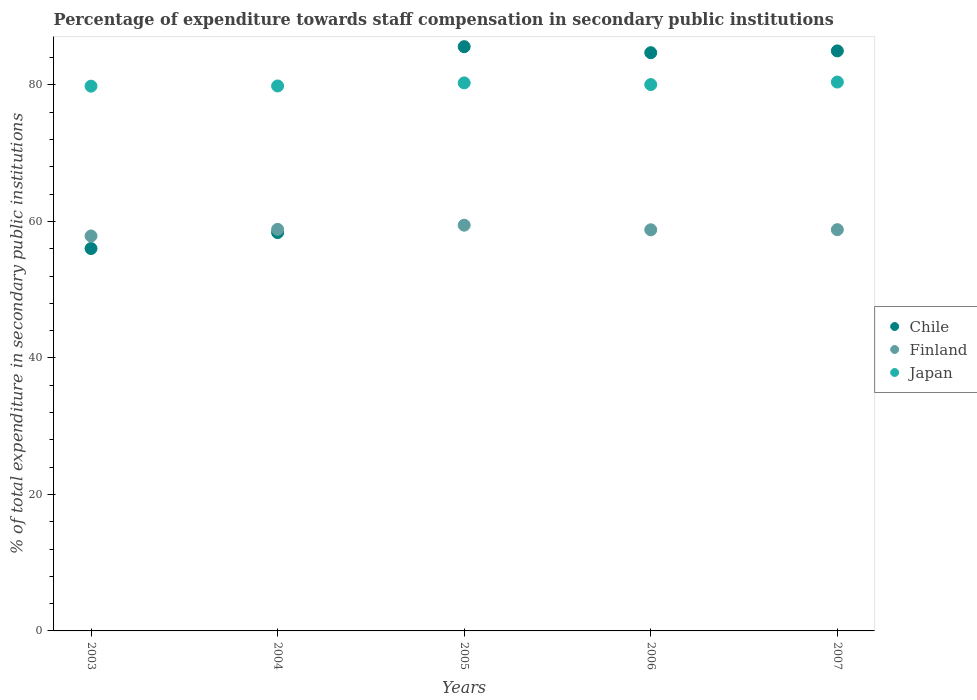How many different coloured dotlines are there?
Offer a terse response. 3. Is the number of dotlines equal to the number of legend labels?
Offer a very short reply. Yes. What is the percentage of expenditure towards staff compensation in Chile in 2005?
Your answer should be very brief. 85.61. Across all years, what is the maximum percentage of expenditure towards staff compensation in Finland?
Offer a terse response. 59.45. Across all years, what is the minimum percentage of expenditure towards staff compensation in Finland?
Make the answer very short. 57.87. In which year was the percentage of expenditure towards staff compensation in Chile maximum?
Your response must be concise. 2005. In which year was the percentage of expenditure towards staff compensation in Chile minimum?
Offer a terse response. 2003. What is the total percentage of expenditure towards staff compensation in Chile in the graph?
Provide a short and direct response. 369.73. What is the difference between the percentage of expenditure towards staff compensation in Japan in 2003 and that in 2005?
Offer a terse response. -0.48. What is the difference between the percentage of expenditure towards staff compensation in Japan in 2006 and the percentage of expenditure towards staff compensation in Finland in 2007?
Keep it short and to the point. 21.26. What is the average percentage of expenditure towards staff compensation in Finland per year?
Provide a short and direct response. 58.75. In the year 2007, what is the difference between the percentage of expenditure towards staff compensation in Chile and percentage of expenditure towards staff compensation in Finland?
Ensure brevity in your answer.  26.2. What is the ratio of the percentage of expenditure towards staff compensation in Chile in 2005 to that in 2006?
Offer a very short reply. 1.01. What is the difference between the highest and the second highest percentage of expenditure towards staff compensation in Japan?
Your response must be concise. 0.12. What is the difference between the highest and the lowest percentage of expenditure towards staff compensation in Chile?
Provide a succinct answer. 29.58. In how many years, is the percentage of expenditure towards staff compensation in Finland greater than the average percentage of expenditure towards staff compensation in Finland taken over all years?
Give a very brief answer. 4. Is the sum of the percentage of expenditure towards staff compensation in Japan in 2003 and 2006 greater than the maximum percentage of expenditure towards staff compensation in Chile across all years?
Offer a terse response. Yes. Does the percentage of expenditure towards staff compensation in Chile monotonically increase over the years?
Ensure brevity in your answer.  No. Is the percentage of expenditure towards staff compensation in Chile strictly greater than the percentage of expenditure towards staff compensation in Japan over the years?
Your answer should be very brief. No. Is the percentage of expenditure towards staff compensation in Japan strictly less than the percentage of expenditure towards staff compensation in Chile over the years?
Your answer should be very brief. No. How many dotlines are there?
Ensure brevity in your answer.  3. Where does the legend appear in the graph?
Your answer should be compact. Center right. What is the title of the graph?
Your answer should be compact. Percentage of expenditure towards staff compensation in secondary public institutions. What is the label or title of the X-axis?
Keep it short and to the point. Years. What is the label or title of the Y-axis?
Provide a short and direct response. % of total expenditure in secondary public institutions. What is the % of total expenditure in secondary public institutions in Chile in 2003?
Make the answer very short. 56.03. What is the % of total expenditure in secondary public institutions in Finland in 2003?
Give a very brief answer. 57.87. What is the % of total expenditure in secondary public institutions of Japan in 2003?
Keep it short and to the point. 79.82. What is the % of total expenditure in secondary public institutions in Chile in 2004?
Offer a very short reply. 58.37. What is the % of total expenditure in secondary public institutions of Finland in 2004?
Provide a succinct answer. 58.84. What is the % of total expenditure in secondary public institutions in Japan in 2004?
Your answer should be very brief. 79.85. What is the % of total expenditure in secondary public institutions in Chile in 2005?
Make the answer very short. 85.61. What is the % of total expenditure in secondary public institutions of Finland in 2005?
Provide a succinct answer. 59.45. What is the % of total expenditure in secondary public institutions of Japan in 2005?
Give a very brief answer. 80.3. What is the % of total expenditure in secondary public institutions of Chile in 2006?
Your answer should be very brief. 84.73. What is the % of total expenditure in secondary public institutions of Finland in 2006?
Your answer should be very brief. 58.78. What is the % of total expenditure in secondary public institutions in Japan in 2006?
Offer a terse response. 80.06. What is the % of total expenditure in secondary public institutions in Chile in 2007?
Offer a terse response. 84.99. What is the % of total expenditure in secondary public institutions of Finland in 2007?
Keep it short and to the point. 58.8. What is the % of total expenditure in secondary public institutions in Japan in 2007?
Your answer should be compact. 80.43. Across all years, what is the maximum % of total expenditure in secondary public institutions of Chile?
Your response must be concise. 85.61. Across all years, what is the maximum % of total expenditure in secondary public institutions in Finland?
Your answer should be very brief. 59.45. Across all years, what is the maximum % of total expenditure in secondary public institutions in Japan?
Your answer should be compact. 80.43. Across all years, what is the minimum % of total expenditure in secondary public institutions of Chile?
Offer a terse response. 56.03. Across all years, what is the minimum % of total expenditure in secondary public institutions in Finland?
Offer a very short reply. 57.87. Across all years, what is the minimum % of total expenditure in secondary public institutions of Japan?
Ensure brevity in your answer.  79.82. What is the total % of total expenditure in secondary public institutions in Chile in the graph?
Give a very brief answer. 369.73. What is the total % of total expenditure in secondary public institutions of Finland in the graph?
Your answer should be compact. 293.74. What is the total % of total expenditure in secondary public institutions of Japan in the graph?
Provide a short and direct response. 400.47. What is the difference between the % of total expenditure in secondary public institutions in Chile in 2003 and that in 2004?
Your response must be concise. -2.33. What is the difference between the % of total expenditure in secondary public institutions in Finland in 2003 and that in 2004?
Make the answer very short. -0.97. What is the difference between the % of total expenditure in secondary public institutions of Japan in 2003 and that in 2004?
Provide a short and direct response. -0.03. What is the difference between the % of total expenditure in secondary public institutions in Chile in 2003 and that in 2005?
Offer a terse response. -29.58. What is the difference between the % of total expenditure in secondary public institutions of Finland in 2003 and that in 2005?
Make the answer very short. -1.58. What is the difference between the % of total expenditure in secondary public institutions in Japan in 2003 and that in 2005?
Keep it short and to the point. -0.48. What is the difference between the % of total expenditure in secondary public institutions in Chile in 2003 and that in 2006?
Keep it short and to the point. -28.7. What is the difference between the % of total expenditure in secondary public institutions of Finland in 2003 and that in 2006?
Provide a succinct answer. -0.9. What is the difference between the % of total expenditure in secondary public institutions of Japan in 2003 and that in 2006?
Your answer should be very brief. -0.24. What is the difference between the % of total expenditure in secondary public institutions in Chile in 2003 and that in 2007?
Offer a very short reply. -28.96. What is the difference between the % of total expenditure in secondary public institutions in Finland in 2003 and that in 2007?
Make the answer very short. -0.92. What is the difference between the % of total expenditure in secondary public institutions of Japan in 2003 and that in 2007?
Keep it short and to the point. -0.6. What is the difference between the % of total expenditure in secondary public institutions in Chile in 2004 and that in 2005?
Ensure brevity in your answer.  -27.24. What is the difference between the % of total expenditure in secondary public institutions in Finland in 2004 and that in 2005?
Offer a very short reply. -0.61. What is the difference between the % of total expenditure in secondary public institutions of Japan in 2004 and that in 2005?
Your answer should be very brief. -0.45. What is the difference between the % of total expenditure in secondary public institutions in Chile in 2004 and that in 2006?
Provide a short and direct response. -26.36. What is the difference between the % of total expenditure in secondary public institutions of Finland in 2004 and that in 2006?
Provide a short and direct response. 0.07. What is the difference between the % of total expenditure in secondary public institutions in Japan in 2004 and that in 2006?
Offer a very short reply. -0.2. What is the difference between the % of total expenditure in secondary public institutions of Chile in 2004 and that in 2007?
Your response must be concise. -26.63. What is the difference between the % of total expenditure in secondary public institutions in Finland in 2004 and that in 2007?
Ensure brevity in your answer.  0.05. What is the difference between the % of total expenditure in secondary public institutions in Japan in 2004 and that in 2007?
Offer a very short reply. -0.57. What is the difference between the % of total expenditure in secondary public institutions in Chile in 2005 and that in 2006?
Your answer should be compact. 0.88. What is the difference between the % of total expenditure in secondary public institutions in Finland in 2005 and that in 2006?
Your answer should be compact. 0.68. What is the difference between the % of total expenditure in secondary public institutions of Japan in 2005 and that in 2006?
Give a very brief answer. 0.24. What is the difference between the % of total expenditure in secondary public institutions in Chile in 2005 and that in 2007?
Your answer should be very brief. 0.62. What is the difference between the % of total expenditure in secondary public institutions in Finland in 2005 and that in 2007?
Make the answer very short. 0.66. What is the difference between the % of total expenditure in secondary public institutions of Japan in 2005 and that in 2007?
Offer a terse response. -0.12. What is the difference between the % of total expenditure in secondary public institutions of Chile in 2006 and that in 2007?
Give a very brief answer. -0.26. What is the difference between the % of total expenditure in secondary public institutions in Finland in 2006 and that in 2007?
Provide a succinct answer. -0.02. What is the difference between the % of total expenditure in secondary public institutions in Japan in 2006 and that in 2007?
Ensure brevity in your answer.  -0.37. What is the difference between the % of total expenditure in secondary public institutions in Chile in 2003 and the % of total expenditure in secondary public institutions in Finland in 2004?
Provide a succinct answer. -2.81. What is the difference between the % of total expenditure in secondary public institutions in Chile in 2003 and the % of total expenditure in secondary public institutions in Japan in 2004?
Your response must be concise. -23.82. What is the difference between the % of total expenditure in secondary public institutions of Finland in 2003 and the % of total expenditure in secondary public institutions of Japan in 2004?
Provide a short and direct response. -21.98. What is the difference between the % of total expenditure in secondary public institutions of Chile in 2003 and the % of total expenditure in secondary public institutions of Finland in 2005?
Make the answer very short. -3.42. What is the difference between the % of total expenditure in secondary public institutions of Chile in 2003 and the % of total expenditure in secondary public institutions of Japan in 2005?
Provide a short and direct response. -24.27. What is the difference between the % of total expenditure in secondary public institutions in Finland in 2003 and the % of total expenditure in secondary public institutions in Japan in 2005?
Offer a terse response. -22.43. What is the difference between the % of total expenditure in secondary public institutions in Chile in 2003 and the % of total expenditure in secondary public institutions in Finland in 2006?
Provide a succinct answer. -2.75. What is the difference between the % of total expenditure in secondary public institutions in Chile in 2003 and the % of total expenditure in secondary public institutions in Japan in 2006?
Provide a succinct answer. -24.03. What is the difference between the % of total expenditure in secondary public institutions in Finland in 2003 and the % of total expenditure in secondary public institutions in Japan in 2006?
Keep it short and to the point. -22.18. What is the difference between the % of total expenditure in secondary public institutions in Chile in 2003 and the % of total expenditure in secondary public institutions in Finland in 2007?
Offer a very short reply. -2.76. What is the difference between the % of total expenditure in secondary public institutions in Chile in 2003 and the % of total expenditure in secondary public institutions in Japan in 2007?
Offer a very short reply. -24.4. What is the difference between the % of total expenditure in secondary public institutions of Finland in 2003 and the % of total expenditure in secondary public institutions of Japan in 2007?
Provide a short and direct response. -22.55. What is the difference between the % of total expenditure in secondary public institutions of Chile in 2004 and the % of total expenditure in secondary public institutions of Finland in 2005?
Give a very brief answer. -1.09. What is the difference between the % of total expenditure in secondary public institutions of Chile in 2004 and the % of total expenditure in secondary public institutions of Japan in 2005?
Your answer should be compact. -21.94. What is the difference between the % of total expenditure in secondary public institutions in Finland in 2004 and the % of total expenditure in secondary public institutions in Japan in 2005?
Give a very brief answer. -21.46. What is the difference between the % of total expenditure in secondary public institutions of Chile in 2004 and the % of total expenditure in secondary public institutions of Finland in 2006?
Give a very brief answer. -0.41. What is the difference between the % of total expenditure in secondary public institutions of Chile in 2004 and the % of total expenditure in secondary public institutions of Japan in 2006?
Ensure brevity in your answer.  -21.69. What is the difference between the % of total expenditure in secondary public institutions of Finland in 2004 and the % of total expenditure in secondary public institutions of Japan in 2006?
Keep it short and to the point. -21.22. What is the difference between the % of total expenditure in secondary public institutions of Chile in 2004 and the % of total expenditure in secondary public institutions of Finland in 2007?
Your answer should be compact. -0.43. What is the difference between the % of total expenditure in secondary public institutions in Chile in 2004 and the % of total expenditure in secondary public institutions in Japan in 2007?
Make the answer very short. -22.06. What is the difference between the % of total expenditure in secondary public institutions of Finland in 2004 and the % of total expenditure in secondary public institutions of Japan in 2007?
Your answer should be compact. -21.58. What is the difference between the % of total expenditure in secondary public institutions of Chile in 2005 and the % of total expenditure in secondary public institutions of Finland in 2006?
Offer a terse response. 26.83. What is the difference between the % of total expenditure in secondary public institutions of Chile in 2005 and the % of total expenditure in secondary public institutions of Japan in 2006?
Provide a succinct answer. 5.55. What is the difference between the % of total expenditure in secondary public institutions in Finland in 2005 and the % of total expenditure in secondary public institutions in Japan in 2006?
Your answer should be very brief. -20.6. What is the difference between the % of total expenditure in secondary public institutions of Chile in 2005 and the % of total expenditure in secondary public institutions of Finland in 2007?
Offer a very short reply. 26.82. What is the difference between the % of total expenditure in secondary public institutions in Chile in 2005 and the % of total expenditure in secondary public institutions in Japan in 2007?
Keep it short and to the point. 5.18. What is the difference between the % of total expenditure in secondary public institutions in Finland in 2005 and the % of total expenditure in secondary public institutions in Japan in 2007?
Your response must be concise. -20.97. What is the difference between the % of total expenditure in secondary public institutions in Chile in 2006 and the % of total expenditure in secondary public institutions in Finland in 2007?
Make the answer very short. 25.93. What is the difference between the % of total expenditure in secondary public institutions of Chile in 2006 and the % of total expenditure in secondary public institutions of Japan in 2007?
Keep it short and to the point. 4.3. What is the difference between the % of total expenditure in secondary public institutions of Finland in 2006 and the % of total expenditure in secondary public institutions of Japan in 2007?
Make the answer very short. -21.65. What is the average % of total expenditure in secondary public institutions of Chile per year?
Ensure brevity in your answer.  73.95. What is the average % of total expenditure in secondary public institutions in Finland per year?
Your answer should be compact. 58.75. What is the average % of total expenditure in secondary public institutions in Japan per year?
Make the answer very short. 80.09. In the year 2003, what is the difference between the % of total expenditure in secondary public institutions in Chile and % of total expenditure in secondary public institutions in Finland?
Make the answer very short. -1.84. In the year 2003, what is the difference between the % of total expenditure in secondary public institutions of Chile and % of total expenditure in secondary public institutions of Japan?
Make the answer very short. -23.79. In the year 2003, what is the difference between the % of total expenditure in secondary public institutions in Finland and % of total expenditure in secondary public institutions in Japan?
Provide a succinct answer. -21.95. In the year 2004, what is the difference between the % of total expenditure in secondary public institutions of Chile and % of total expenditure in secondary public institutions of Finland?
Make the answer very short. -0.48. In the year 2004, what is the difference between the % of total expenditure in secondary public institutions in Chile and % of total expenditure in secondary public institutions in Japan?
Your answer should be compact. -21.49. In the year 2004, what is the difference between the % of total expenditure in secondary public institutions in Finland and % of total expenditure in secondary public institutions in Japan?
Provide a succinct answer. -21.01. In the year 2005, what is the difference between the % of total expenditure in secondary public institutions in Chile and % of total expenditure in secondary public institutions in Finland?
Your answer should be very brief. 26.16. In the year 2005, what is the difference between the % of total expenditure in secondary public institutions of Chile and % of total expenditure in secondary public institutions of Japan?
Give a very brief answer. 5.31. In the year 2005, what is the difference between the % of total expenditure in secondary public institutions of Finland and % of total expenditure in secondary public institutions of Japan?
Provide a succinct answer. -20.85. In the year 2006, what is the difference between the % of total expenditure in secondary public institutions of Chile and % of total expenditure in secondary public institutions of Finland?
Provide a short and direct response. 25.95. In the year 2006, what is the difference between the % of total expenditure in secondary public institutions of Chile and % of total expenditure in secondary public institutions of Japan?
Provide a short and direct response. 4.67. In the year 2006, what is the difference between the % of total expenditure in secondary public institutions of Finland and % of total expenditure in secondary public institutions of Japan?
Give a very brief answer. -21.28. In the year 2007, what is the difference between the % of total expenditure in secondary public institutions in Chile and % of total expenditure in secondary public institutions in Finland?
Provide a succinct answer. 26.2. In the year 2007, what is the difference between the % of total expenditure in secondary public institutions of Chile and % of total expenditure in secondary public institutions of Japan?
Make the answer very short. 4.56. In the year 2007, what is the difference between the % of total expenditure in secondary public institutions of Finland and % of total expenditure in secondary public institutions of Japan?
Offer a terse response. -21.63. What is the ratio of the % of total expenditure in secondary public institutions in Finland in 2003 to that in 2004?
Provide a short and direct response. 0.98. What is the ratio of the % of total expenditure in secondary public institutions in Japan in 2003 to that in 2004?
Offer a terse response. 1. What is the ratio of the % of total expenditure in secondary public institutions of Chile in 2003 to that in 2005?
Your answer should be compact. 0.65. What is the ratio of the % of total expenditure in secondary public institutions of Finland in 2003 to that in 2005?
Your response must be concise. 0.97. What is the ratio of the % of total expenditure in secondary public institutions of Chile in 2003 to that in 2006?
Provide a succinct answer. 0.66. What is the ratio of the % of total expenditure in secondary public institutions in Finland in 2003 to that in 2006?
Make the answer very short. 0.98. What is the ratio of the % of total expenditure in secondary public institutions in Chile in 2003 to that in 2007?
Your answer should be very brief. 0.66. What is the ratio of the % of total expenditure in secondary public institutions of Finland in 2003 to that in 2007?
Offer a terse response. 0.98. What is the ratio of the % of total expenditure in secondary public institutions in Japan in 2003 to that in 2007?
Offer a terse response. 0.99. What is the ratio of the % of total expenditure in secondary public institutions of Chile in 2004 to that in 2005?
Your answer should be very brief. 0.68. What is the ratio of the % of total expenditure in secondary public institutions in Finland in 2004 to that in 2005?
Make the answer very short. 0.99. What is the ratio of the % of total expenditure in secondary public institutions in Japan in 2004 to that in 2005?
Your answer should be very brief. 0.99. What is the ratio of the % of total expenditure in secondary public institutions of Chile in 2004 to that in 2006?
Keep it short and to the point. 0.69. What is the ratio of the % of total expenditure in secondary public institutions of Japan in 2004 to that in 2006?
Provide a short and direct response. 1. What is the ratio of the % of total expenditure in secondary public institutions of Chile in 2004 to that in 2007?
Ensure brevity in your answer.  0.69. What is the ratio of the % of total expenditure in secondary public institutions in Chile in 2005 to that in 2006?
Your answer should be very brief. 1.01. What is the ratio of the % of total expenditure in secondary public institutions of Finland in 2005 to that in 2006?
Offer a terse response. 1.01. What is the ratio of the % of total expenditure in secondary public institutions of Chile in 2005 to that in 2007?
Offer a very short reply. 1.01. What is the ratio of the % of total expenditure in secondary public institutions in Finland in 2005 to that in 2007?
Make the answer very short. 1.01. What is the difference between the highest and the second highest % of total expenditure in secondary public institutions of Chile?
Your response must be concise. 0.62. What is the difference between the highest and the second highest % of total expenditure in secondary public institutions of Finland?
Offer a terse response. 0.61. What is the difference between the highest and the second highest % of total expenditure in secondary public institutions in Japan?
Give a very brief answer. 0.12. What is the difference between the highest and the lowest % of total expenditure in secondary public institutions of Chile?
Ensure brevity in your answer.  29.58. What is the difference between the highest and the lowest % of total expenditure in secondary public institutions of Finland?
Offer a very short reply. 1.58. What is the difference between the highest and the lowest % of total expenditure in secondary public institutions in Japan?
Give a very brief answer. 0.6. 